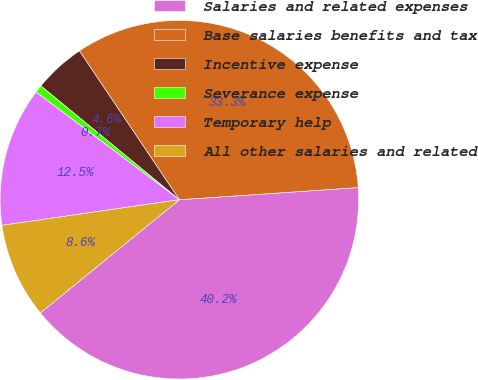<chart> <loc_0><loc_0><loc_500><loc_500><pie_chart><fcel>Salaries and related expenses<fcel>Base salaries benefits and tax<fcel>Incentive expense<fcel>Severance expense<fcel>Temporary help<fcel>All other salaries and related<nl><fcel>40.2%<fcel>33.33%<fcel>4.64%<fcel>0.69%<fcel>12.54%<fcel>8.59%<nl></chart> 